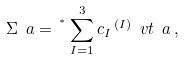Convert formula to latex. <formula><loc_0><loc_0><loc_500><loc_500>\Sigma _ { \ } a = \, ^ { ^ { * } } \sum _ { I = 1 } ^ { 3 } c _ { I } \, ^ { ( I ) } \ v t _ { \ } a \, ,</formula> 